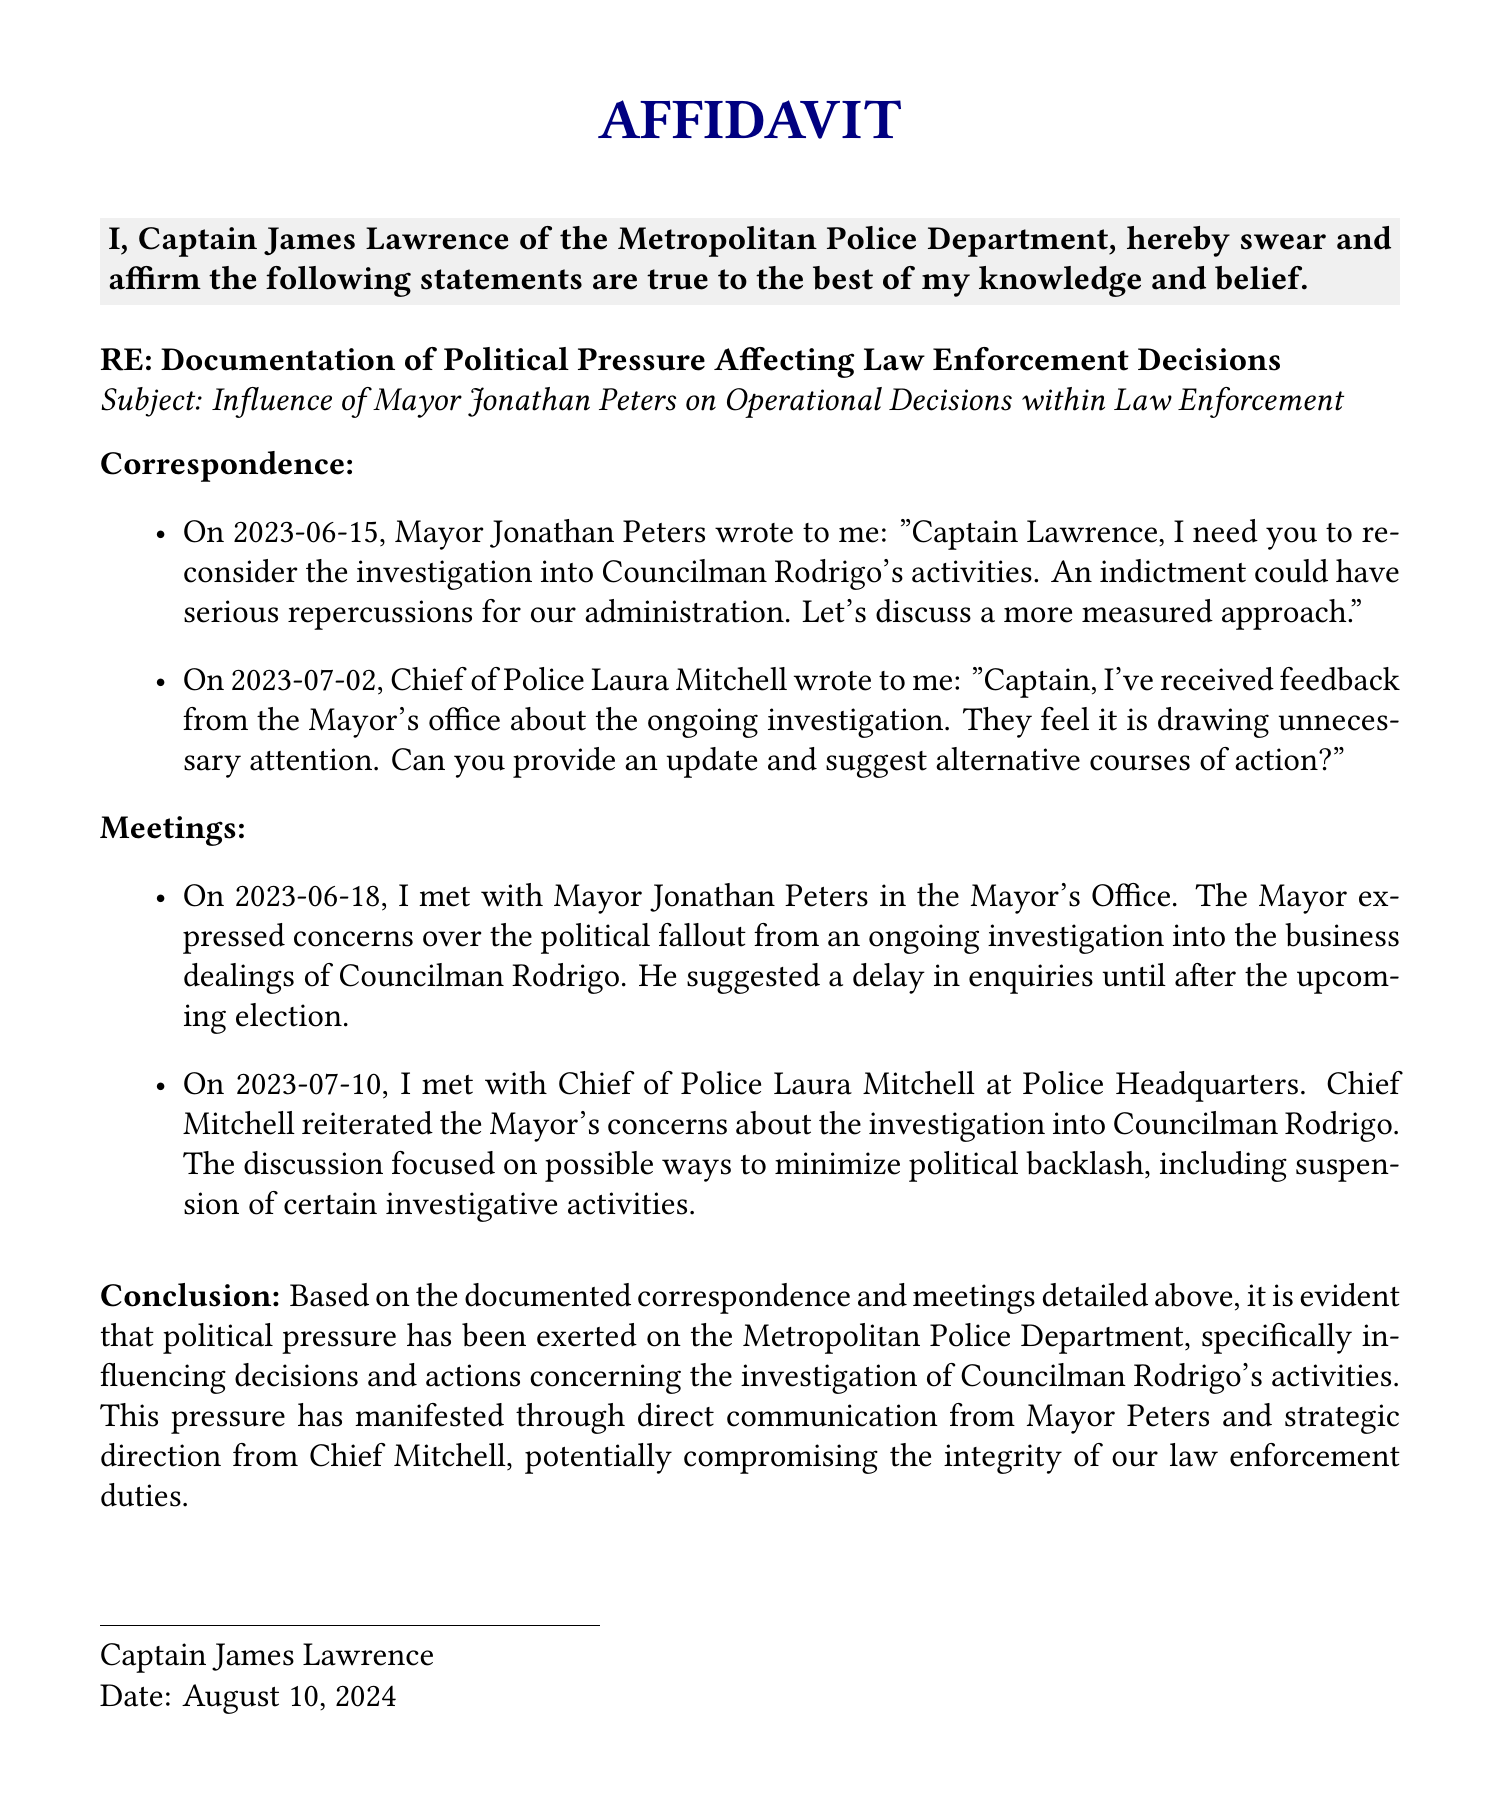What is the date of the first correspondence? The first correspondence was dated June 15, 2023, as stated in the document.
Answer: June 15, 2023 Who wrote to Captain Lawrence about reconsidering the investigation? The document states that Mayor Jonathan Peters wrote to Captain Lawrence regarding the investigation into Councilman Rodrigo's activities.
Answer: Mayor Jonathan Peters What was the subject of the meetings mentioned in the affidavit? The meetings focused on the investigation into the business dealings of Councilman Rodrigo, highlighting concerns over political fallout.
Answer: Investigation into Councilman Rodrigo's activities On what date did Captain Lawrence meet with the Mayor? The document indicates that Captain Lawrence met with Mayor Jonathan Peters on June 18, 2023.
Answer: June 18, 2023 What is the conclusion of the affidavit? The conclusion summarizes that political pressure has been exerted on the department, influencing investigation decisions regarding Councilman Rodrigo.
Answer: Political pressure has been exerted on the department Who is the Chief of Police mentioned in the document? The document identifies Laura Mitchell as the Chief of Police who communicated concerns about the investigation.
Answer: Laura Mitchell 